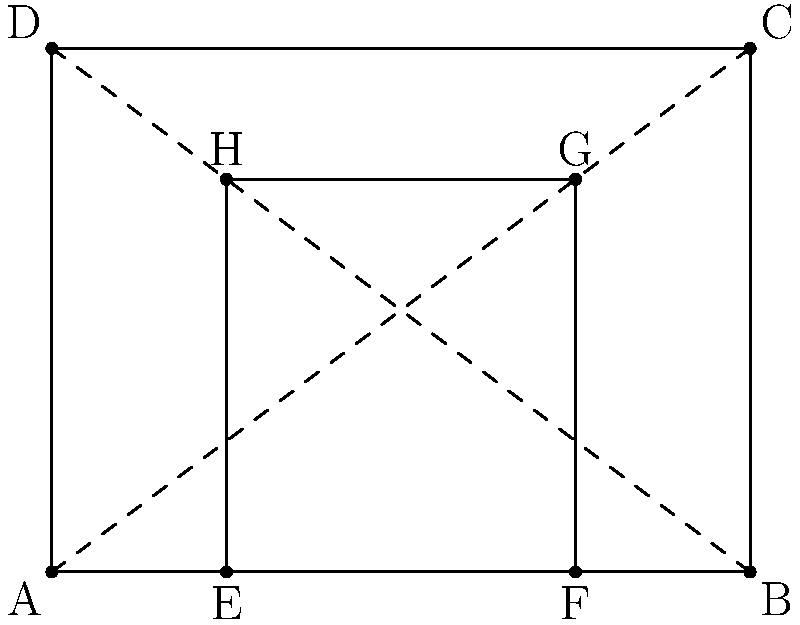In the above diagram of a classical temple facade, rectangle ABCD represents the entire facade, while rectangle EFGH represents the entrance. The facade follows the golden ratio principle. If the width of the facade (AB) is 20 meters, what is the height of the entrance (GH) in meters? Express your answer as a fraction in terms of $\phi$, where $\phi$ represents the golden ratio $(1+\sqrt{5})/2$. To solve this problem, we'll follow these steps:

1) In a golden rectangle, the ratio of the longer side to the shorter side is equal to $\phi$. So, for rectangle ABCD:
   $\frac{AB}{AD} = \phi$

2) We're given that AB = 20 meters. Let's express AD in terms of $\phi$:
   $\frac{20}{AD} = \phi$
   $AD = \frac{20}{\phi}$ meters

3) Now, let's focus on the entrance rectangle EFGH. It's also a golden rectangle, so:
   $\frac{EF}{EH} = \phi$

4) We can see that EF is 1/2 of AB (as E and F divide AB into three equal parts). So:
   $EF = 10$ meters

5) Now we can find EH:
   $\frac{10}{EH} = \phi$
   $EH = \frac{10}{\phi}$ meters

6) The height of the entrance (GH) is 3/4 of EH (as G divides EH into four equal parts, with three parts above G). So:
   $GH = \frac{3}{4} \cdot \frac{10}{\phi} = \frac{15}{2\phi}$ meters

Therefore, the height of the entrance is $\frac{15}{2\phi}$ meters.
Answer: $\frac{15}{2\phi}$ meters 